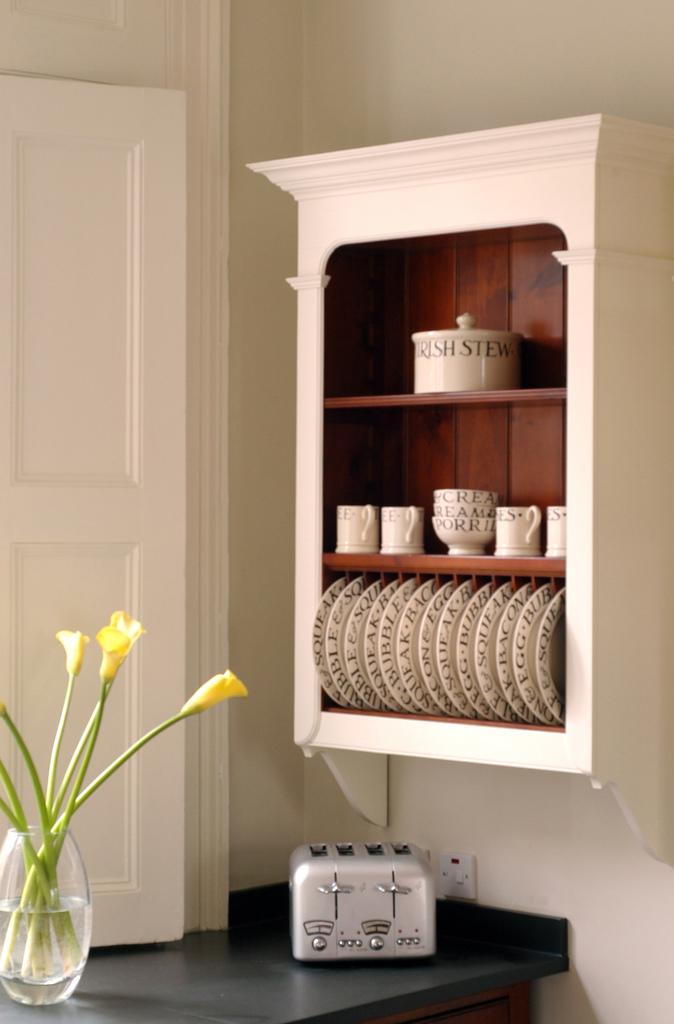What type of stew goes in the pot on top?
Make the answer very short. Irish. What does the top mug say?
Your response must be concise. Irish stew. 